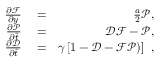<formula> <loc_0><loc_0><loc_500><loc_500>\begin{array} { r l r } { \frac { \partial \mathcal { F } } { \partial y } } & = } & { \frac { a } { 2 } \mathcal { P } , } \\ { \frac { \partial \mathcal { P } } { \partial \hat { t } } } & = } & { \mathcal { D } \mathcal { F } - \mathcal { P } , } \\ { \frac { \partial \mathcal { D } } { \partial \hat { t } } } & = } & { \gamma \left [ 1 - \mathcal { D } - \mathcal { F } \mathcal { P } ) \right ] , } \end{array}</formula> 